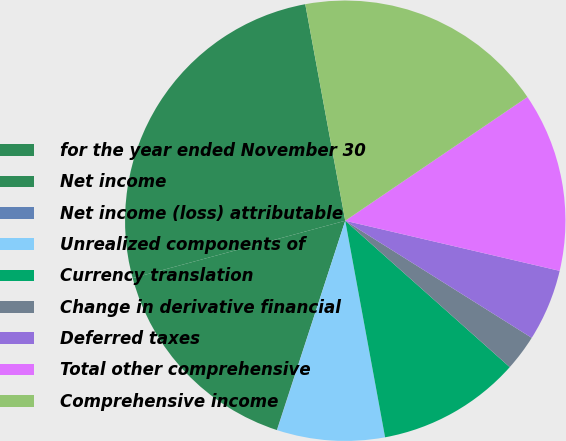<chart> <loc_0><loc_0><loc_500><loc_500><pie_chart><fcel>for the year ended November 30<fcel>Net income<fcel>Net income (loss) attributable<fcel>Unrealized components of<fcel>Currency translation<fcel>Change in derivative financial<fcel>Deferred taxes<fcel>Total other comprehensive<fcel>Comprehensive income<nl><fcel>26.29%<fcel>15.78%<fcel>0.02%<fcel>7.9%<fcel>10.53%<fcel>2.65%<fcel>5.27%<fcel>13.15%<fcel>18.41%<nl></chart> 